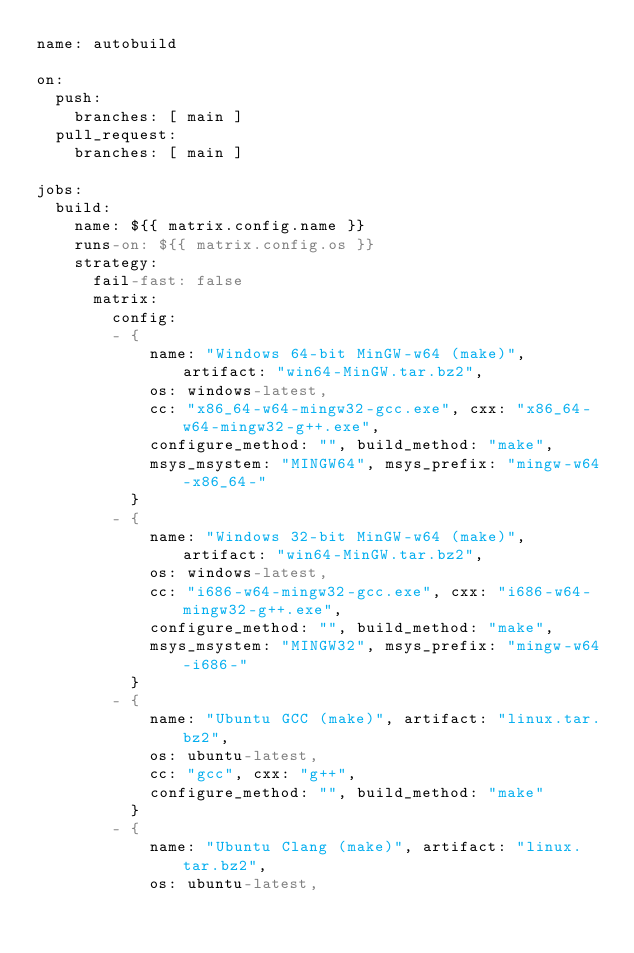<code> <loc_0><loc_0><loc_500><loc_500><_YAML_>name: autobuild

on:
  push:
    branches: [ main ]
  pull_request:
    branches: [ main ]

jobs:
  build:
    name: ${{ matrix.config.name }}
    runs-on: ${{ matrix.config.os }}
    strategy:
      fail-fast: false
      matrix:
        config:
        - {
            name: "Windows 64-bit MinGW-w64 (make)", artifact: "win64-MinGW.tar.bz2",
            os: windows-latest,
            cc: "x86_64-w64-mingw32-gcc.exe", cxx: "x86_64-w64-mingw32-g++.exe",
            configure_method: "", build_method: "make",
            msys_msystem: "MINGW64", msys_prefix: "mingw-w64-x86_64-"
          }
        - {
            name: "Windows 32-bit MinGW-w64 (make)", artifact: "win64-MinGW.tar.bz2",
            os: windows-latest,
            cc: "i686-w64-mingw32-gcc.exe", cxx: "i686-w64-mingw32-g++.exe",
            configure_method: "", build_method: "make",
            msys_msystem: "MINGW32", msys_prefix: "mingw-w64-i686-"
          }
        - {
            name: "Ubuntu GCC (make)", artifact: "linux.tar.bz2",
            os: ubuntu-latest,
            cc: "gcc", cxx: "g++",
            configure_method: "", build_method: "make"
          }
        - {
            name: "Ubuntu Clang (make)", artifact: "linux.tar.bz2",
            os: ubuntu-latest,</code> 